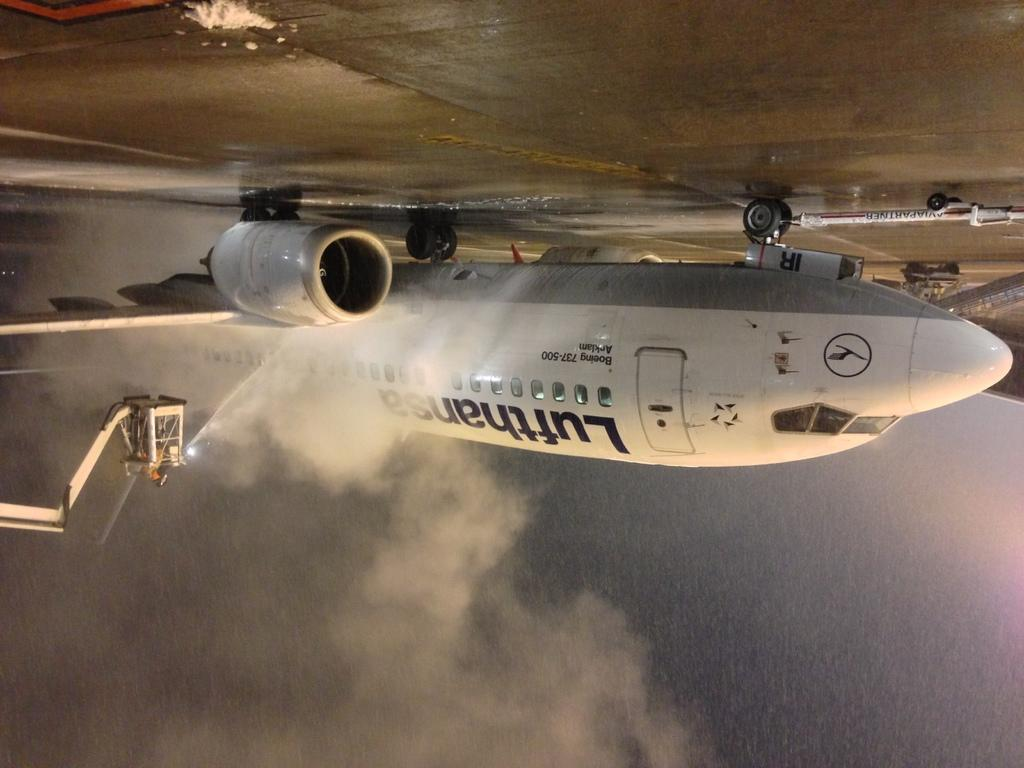<image>
Write a terse but informative summary of the picture. A Lufthansa passenger jet is on a rainy runway. 